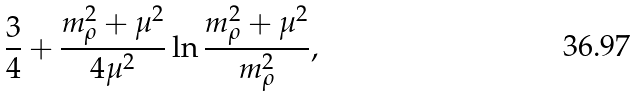<formula> <loc_0><loc_0><loc_500><loc_500>\frac { 3 } { 4 } + \frac { m ^ { 2 } _ { \rho } + \mu ^ { 2 } } { 4 \mu ^ { 2 } } \ln \frac { m ^ { 2 } _ { \rho } + \mu ^ { 2 } } { m ^ { 2 } _ { \rho } } ,</formula> 